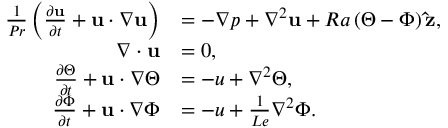<formula> <loc_0><loc_0><loc_500><loc_500>\begin{array} { r l } { \frac { 1 } { P r } \left ( \frac { \partial u } { \partial t } + u \cdot \nabla u \right ) } & { = - \nabla p + \nabla ^ { 2 } u + R a \left ( \Theta - \Phi \right ) \hat { z } , } \\ { \nabla \cdot u } & { = 0 , } \\ { \frac { \partial \Theta } { \partial t } + u \cdot \nabla \Theta } & { = - u + \nabla ^ { 2 } \Theta , } \\ { \frac { \partial \Phi } { \partial t } + u \cdot \nabla \Phi } & { = - u + \frac { 1 } { L e } \nabla ^ { 2 } \Phi . } \end{array}</formula> 